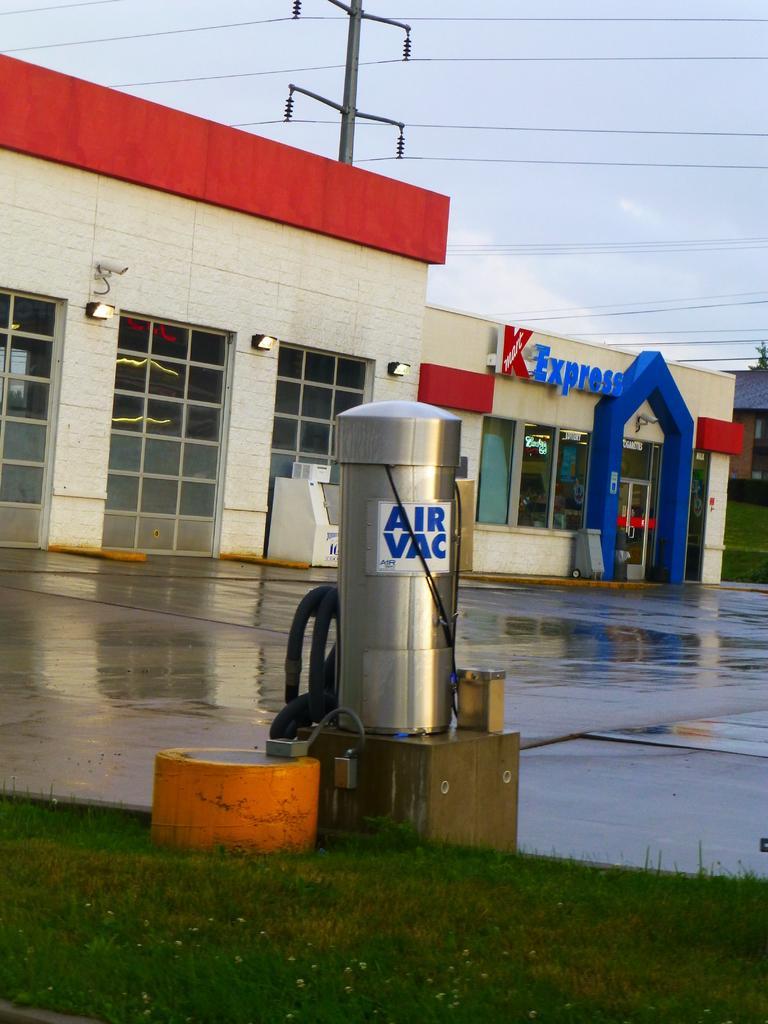Describe this image in one or two sentences. At the bottom of the on the ground there is grass. And also there is a machine. Behind the machine there is floor. In the background there are stores with glass walls, pillars, lamps and roofs. And also there is a name on the wall. Behind the store there is an electrical pole with wires. 